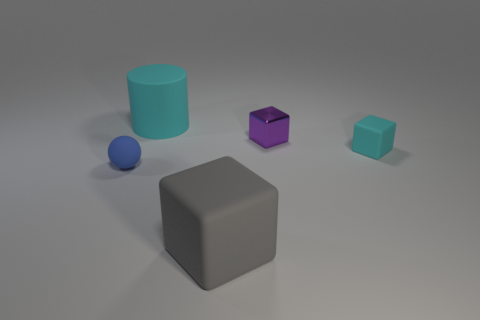Add 3 blue objects. How many objects exist? 8 Subtract all matte cubes. How many cubes are left? 1 Subtract 1 balls. How many balls are left? 0 Subtract all cylinders. How many objects are left? 4 Subtract all cyan cubes. How many cubes are left? 2 Subtract all cyan cubes. Subtract all green balls. How many cubes are left? 2 Subtract all purple blocks. How many green cylinders are left? 0 Subtract all large rubber cylinders. Subtract all gray objects. How many objects are left? 3 Add 1 cylinders. How many cylinders are left? 2 Add 2 small cyan rubber cubes. How many small cyan rubber cubes exist? 3 